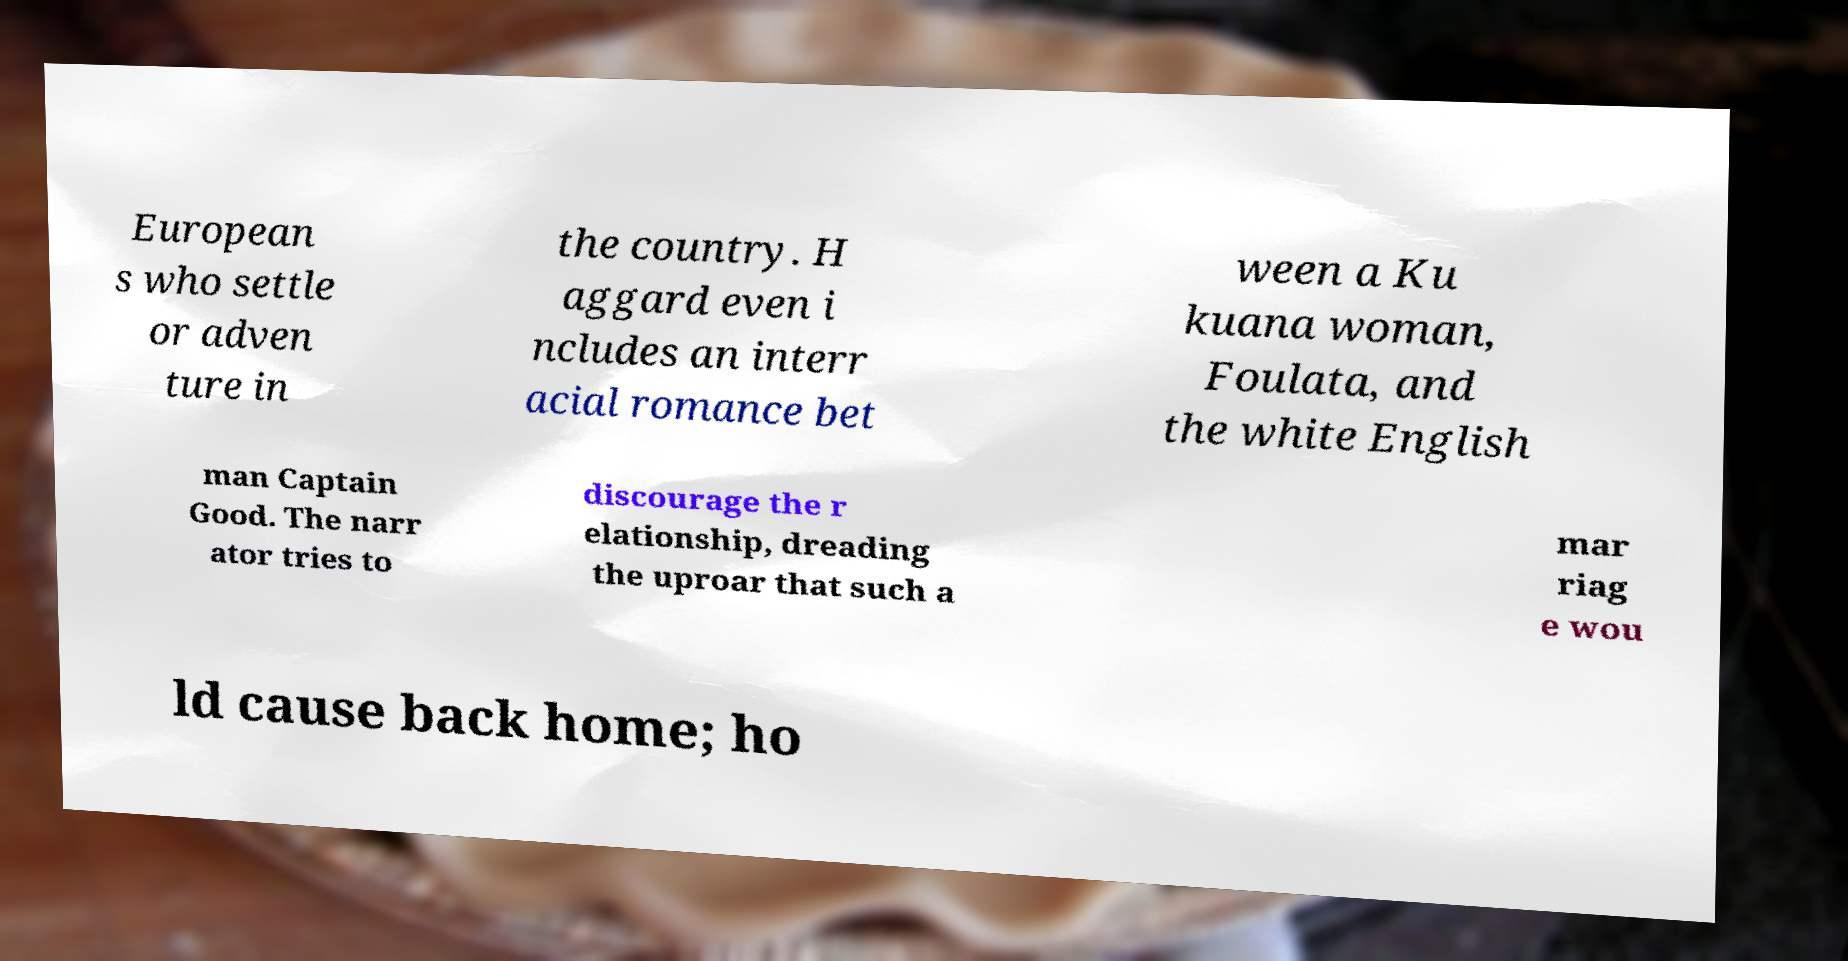Could you extract and type out the text from this image? European s who settle or adven ture in the country. H aggard even i ncludes an interr acial romance bet ween a Ku kuana woman, Foulata, and the white English man Captain Good. The narr ator tries to discourage the r elationship, dreading the uproar that such a mar riag e wou ld cause back home; ho 